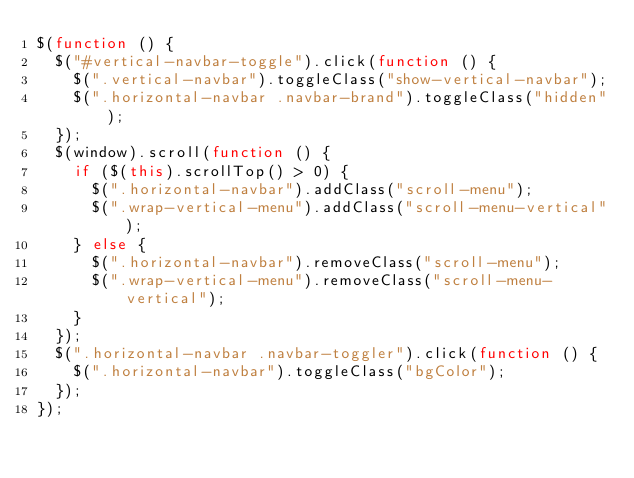<code> <loc_0><loc_0><loc_500><loc_500><_JavaScript_>$(function () {
  $("#vertical-navbar-toggle").click(function () {
    $(".vertical-navbar").toggleClass("show-vertical-navbar");
    $(".horizontal-navbar .navbar-brand").toggleClass("hidden");
  });
  $(window).scroll(function () {
    if ($(this).scrollTop() > 0) {
      $(".horizontal-navbar").addClass("scroll-menu");
      $(".wrap-vertical-menu").addClass("scroll-menu-vertical");
    } else {
      $(".horizontal-navbar").removeClass("scroll-menu");
      $(".wrap-vertical-menu").removeClass("scroll-menu-vertical");
    }
  });
  $(".horizontal-navbar .navbar-toggler").click(function () {
    $(".horizontal-navbar").toggleClass("bgColor");
  });
});
</code> 